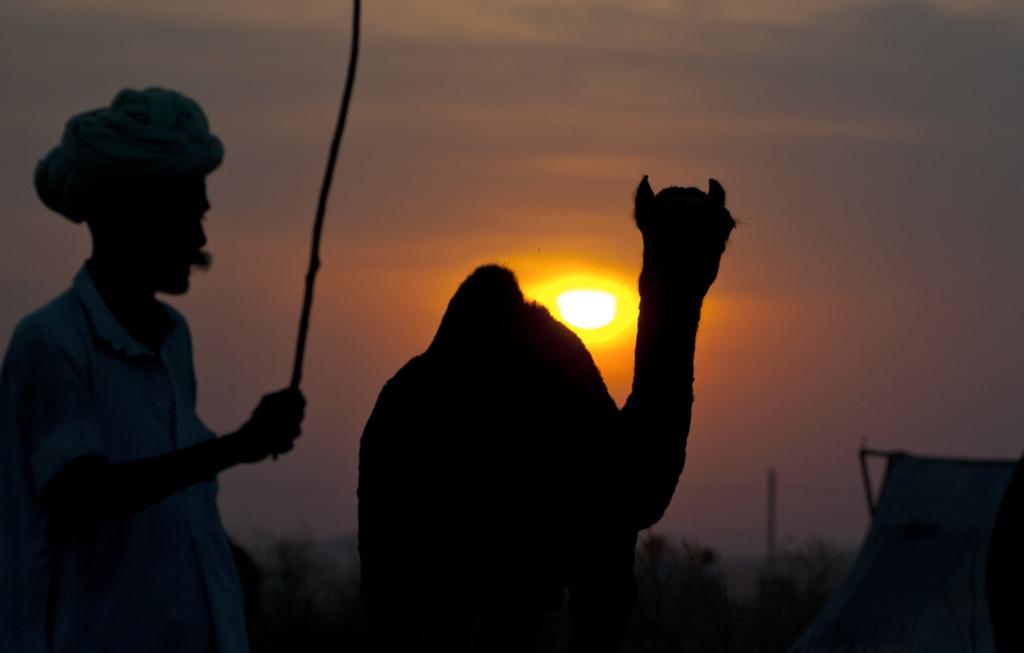What is the main subject of the image? There is a person in the image. What is the person wearing? The person is wearing a dress. What is the person holding in the image? The person is holding a stick. Can you describe the animal in the image? There is an animal in the image, but no specific details are provided about its appearance or behavior. What can be seen in the background of the image? There is a tent, trees, the sun, and the sky visible in the background of the image. What type of marble is being used for the volleyball game in the image? There is no volleyball game present in the image, and therefore no marble or any other sports equipment can be observed. What type of treatment is being administered to the person in the image? There is no indication in the image that the person is receiving any treatment or medical care. 